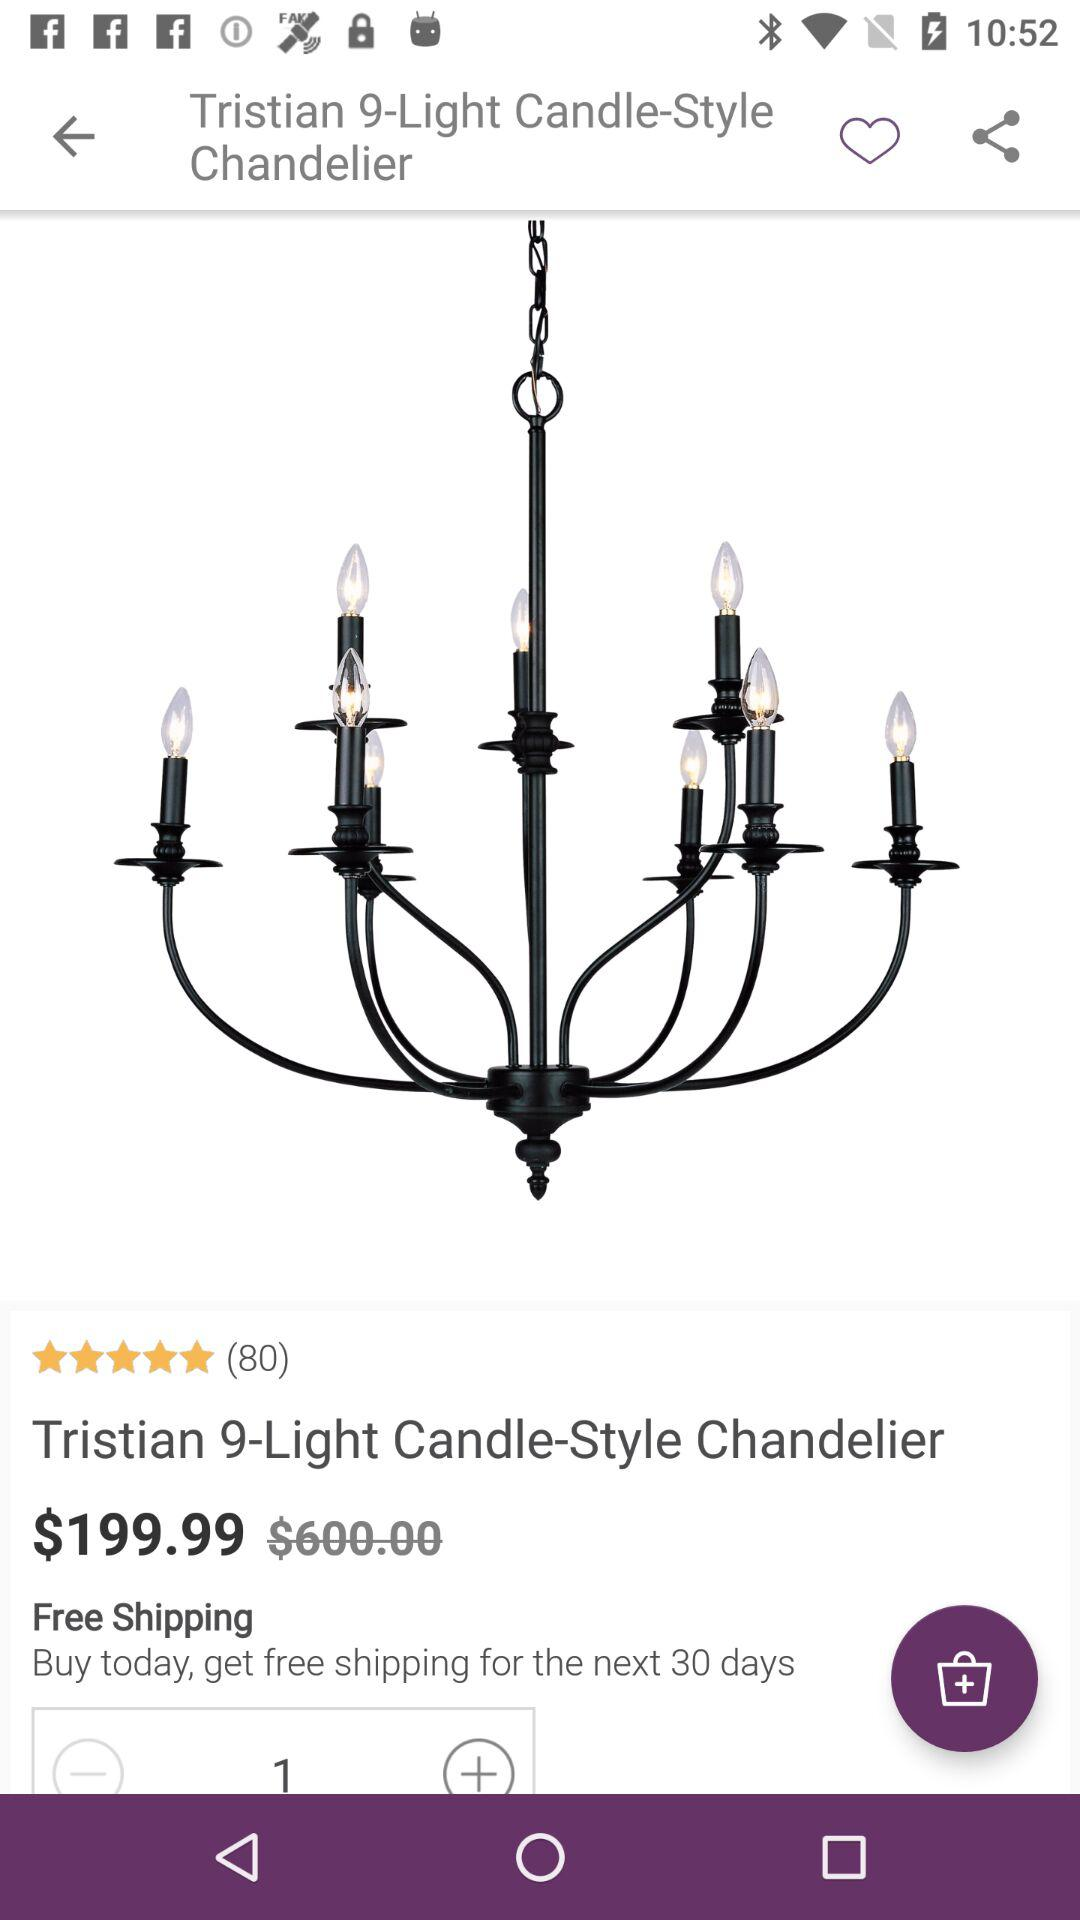What is the rating of the product? The rating of the product is 5 stars. 